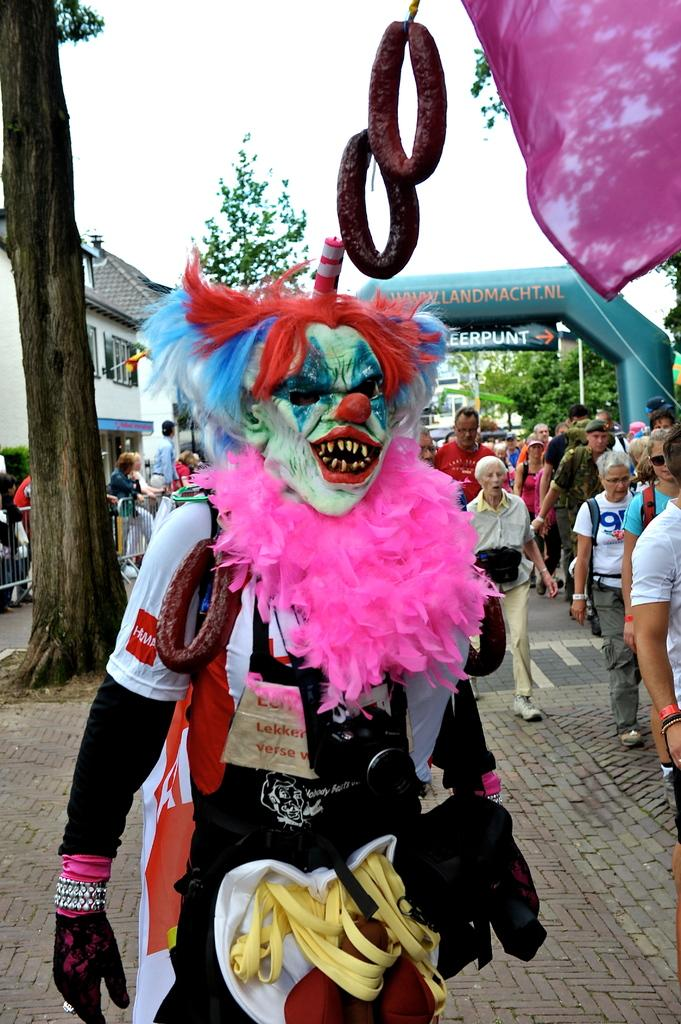What is the main subject of the image? There is a man in the image. What is the man wearing? The man is wearing a costume. Where is the man standing? The man is standing on a pavement. What can be seen in the background of the image? There are people, trees, houses, and an arch visible in the background of the image. What type of spark can be seen coming from the man's costume in the image? There is no spark visible in the image; the man is simply wearing a costume. How many dogs are present in the image? There are no dogs present in the image. 